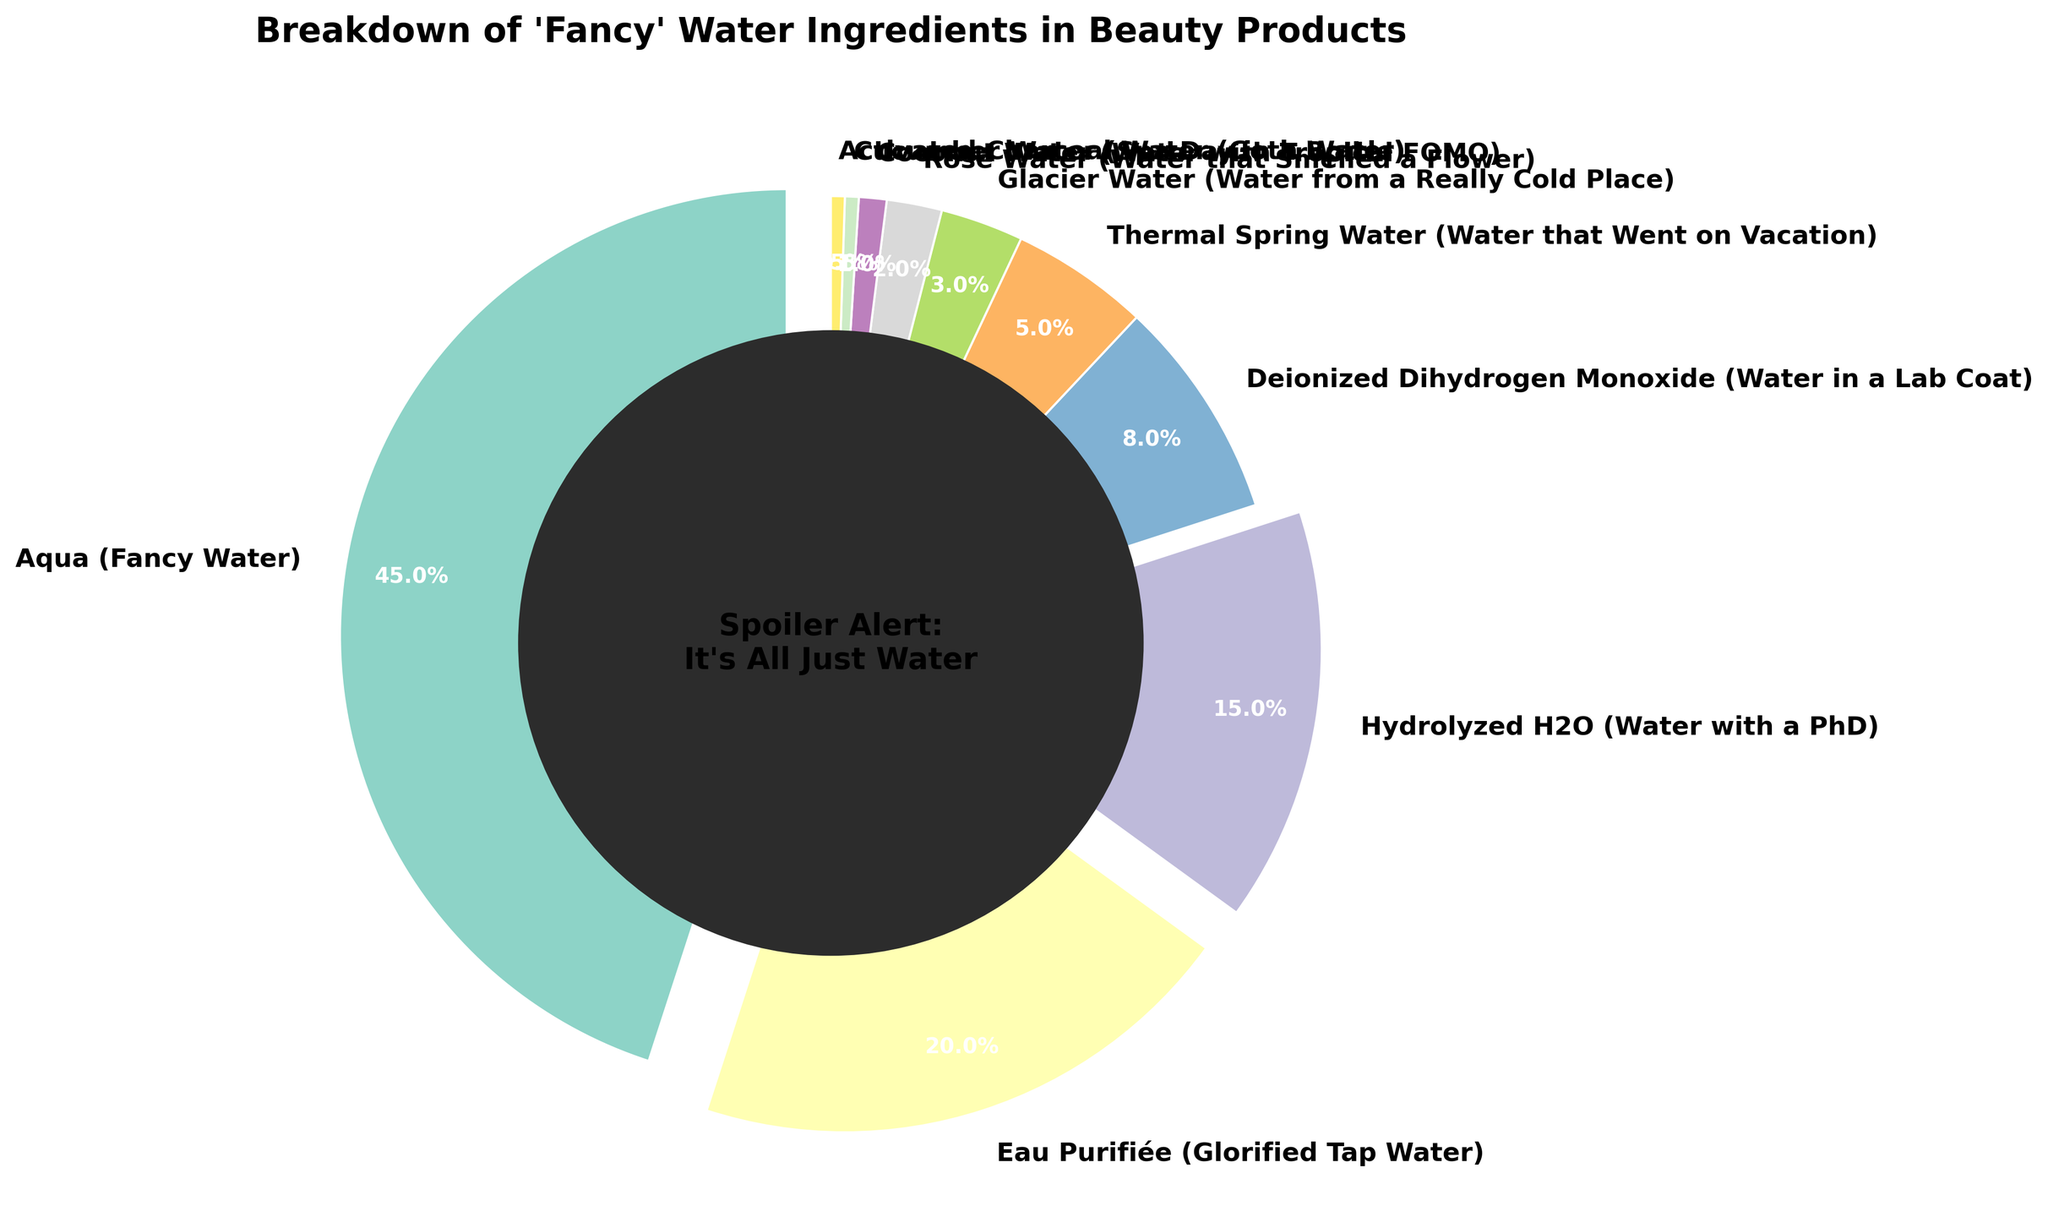which ingredient has the highest percentage of "fancy" water? By looking at the pie chart, we can see that Aqua (Fancy Water) occupies the largest portion of the pie with 45% of the total.
Answer: Aqua (Fancy Water) what's the combined percentage of Thermal Spring Water and Glacier Water? Thermal Spring Water is 5% and Glacier Water is 3%. Adding them together: 5% + 3% = 8%.
Answer: 8% how much more is the percentage of Aqua (Fancy Water) compared to Deionized Dihydrogen Monoxide (Water in a Lab Coat)? Aqua (Fancy Water) is 45% and Deionized Dihydrogen Monoxide is 8%. The difference is: 45% - 8% = 37%.
Answer: 37% which ingredient has the smallest percentage? The smallest percentages in the pie chart are Cucumber Water and Activated Charcoal Water, each with 0.5%.
Answer: Cucumber Water or Activated Charcoal Water if we combine the percentages of Coconut Water, Cucumber Water, and Activated Charcoal Water, what would be their total percentage? The percentage of Coconut Water is 1%, Cucumber Water is 0.5%, and Activated Charcoal Water is 0.5%. Their combined percentage is: 1% + 0.5% + 0.5% = 2%.
Answer: 2% which three ingredients have the least percentages, and what's their total percentage? The three ingredients with the least percentages are Rose Water (2%), Coconut Water (1%), and both Cucumber Water and Activated Charcoal Water, which are 0.5% each. We sum these values: 2% + 1% + 0.5% + 0.5% = 4%.
Answer: Rose Water, Coconut Water, Cucumber Water, Activated Charcoal Water; 4% what's the difference in percentage between Hydrolyzed H2O (Water with a PhD) and Glacier Water? Hydrolyzed H2O has a percentage of 15% and Glacier Water has 3%. The difference is: 15% - 3% = 12%.
Answer: 12% what percentage do ingredients with less than 5% contribute in total, and list their names? Ingredients contributing less than 5% are Glacier Water (3%), Rose Water (2%), Coconut Water (1%), Cucumber Water (0.5%), and Activated Charcoal Water (0.5%). Their total is: 3% + 2% + 1% + 0.5% + 0.5% = 7%.
Answer: 7%; Glacier Water, Rose Water, Coconut Water, Cucumber Water, Activated Charcoal Water 